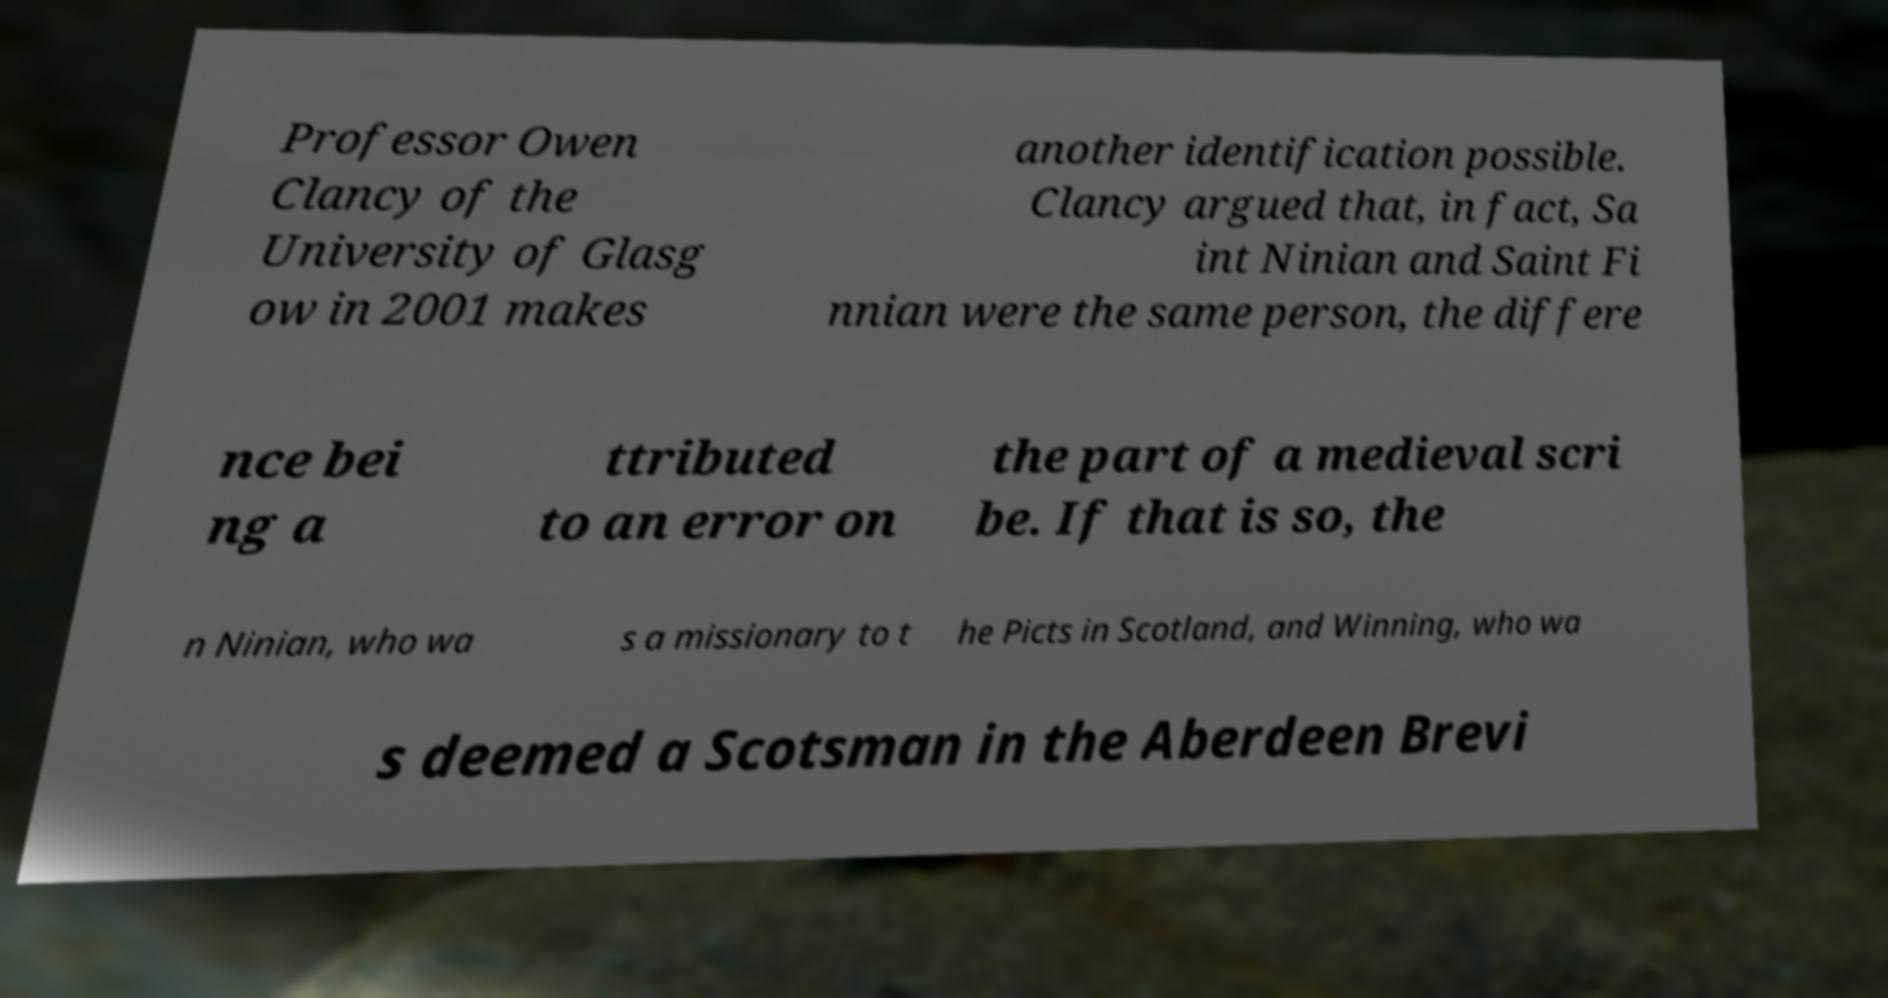Can you read and provide the text displayed in the image?This photo seems to have some interesting text. Can you extract and type it out for me? Professor Owen Clancy of the University of Glasg ow in 2001 makes another identification possible. Clancy argued that, in fact, Sa int Ninian and Saint Fi nnian were the same person, the differe nce bei ng a ttributed to an error on the part of a medieval scri be. If that is so, the n Ninian, who wa s a missionary to t he Picts in Scotland, and Winning, who wa s deemed a Scotsman in the Aberdeen Brevi 